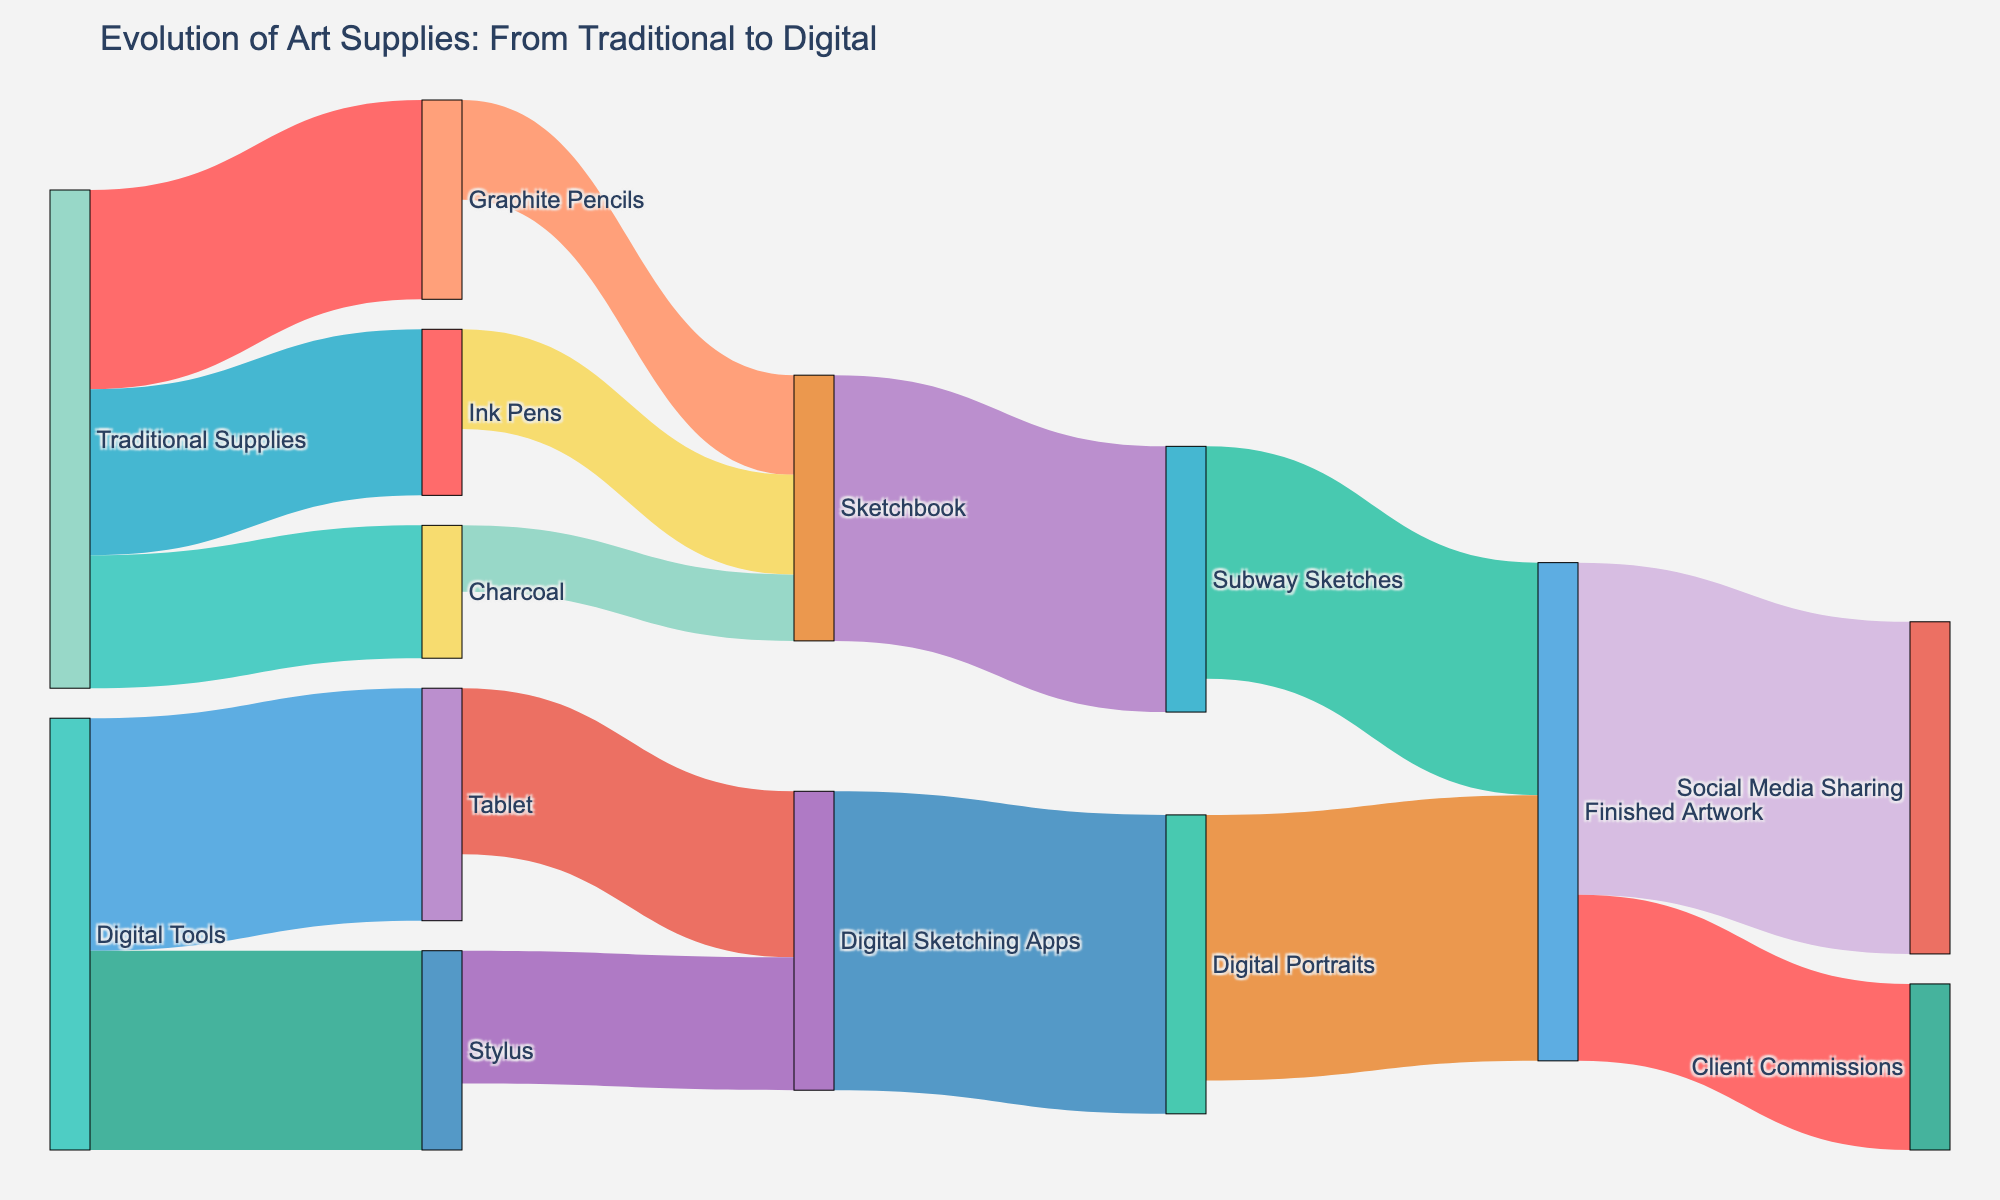What is the title of this diagram? The title is displayed at the top of the figure, which is "Evolution of Art Supplies: From Traditional to Digital."
Answer: Evolution of Art Supplies: From Traditional to Digital Which traditional supplies have the highest number of links to art tools? By observing the diagram, we see that "Traditional Supplies" have outgoing links to "Graphite Pencils," "Charcoal," and "Ink Pens." Counting these links, we get three links.
Answer: Traditional Supplies What is the total value of digital tools used? The values of digital tools, "Tablet" and "Stylus," are given as 35 and 30 respectively. Adding them together, we get 35 + 30 = 65.
Answer: 65 How many values are linked to "Finished Artwork"? By looking at the figure, we can see that "Subway Sketches" and "Digital Portraits" link to "Finished Artwork," making it two links.
Answer: 2 Which art tools contribute most to "Sketchbook"? The values of incoming links to "Sketchbook" are from "Graphite Pencils" (15), "Charcoal" (10), and "Ink Pens" (15). Comparing these values, both "Graphite Pencils" and "Ink Pens" contribute the most equally.
Answer: Graphite Pencils and Ink Pens Compare the total values of "Traditional Supplies" and "Digital Tools." Which one is higher? Traditional supplies sum to Graphite Pencils (30) + Charcoal (20) + Ink Pens (25) = 75. Digital tools sum to Tablet (35) + Stylus (30) = 65. Thus, traditional supplies have a higher total value.
Answer: Traditional Supplies What is the final destination with the highest value in the entire diagram? By tracing the values to their final destinations, "Social Media Sharing" has the highest value of 50.
Answer: Social Media Sharing From which supply do the digital sketching apps get the most value? Digital Sketching Apps get values from "Tablet" (25) and "Stylus" (20). Comparing these, "Tablet" provides the most value.
Answer: Tablet What is the value transition from "Sketchbook" to "Finished Artwork"? "Sketchbook" transitions to "Subway Sketches" (40), then to "Finished Artwork" (35). The direct transition is 35 units.
Answer: 35 Compare the values of "Client Commissions" and "Social Media Sharing" flowing from "Finished Artwork." Which one is greater? From "Finished Artwork," the value to "Client Commissions" is 25 and to "Social Media Sharing" is 50. Hence, "Social Media Sharing" is greater.
Answer: Social Media Sharing 